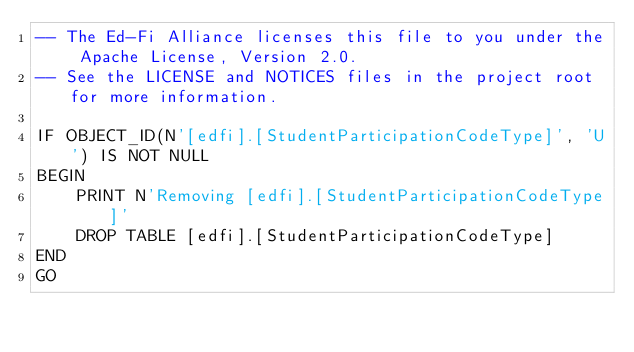<code> <loc_0><loc_0><loc_500><loc_500><_SQL_>-- The Ed-Fi Alliance licenses this file to you under the Apache License, Version 2.0.
-- See the LICENSE and NOTICES files in the project root for more information.

IF OBJECT_ID(N'[edfi].[StudentParticipationCodeType]', 'U') IS NOT NULL
BEGIN
	PRINT N'Removing [edfi].[StudentParticipationCodeType]'
	DROP TABLE [edfi].[StudentParticipationCodeType]
END
GO

</code> 